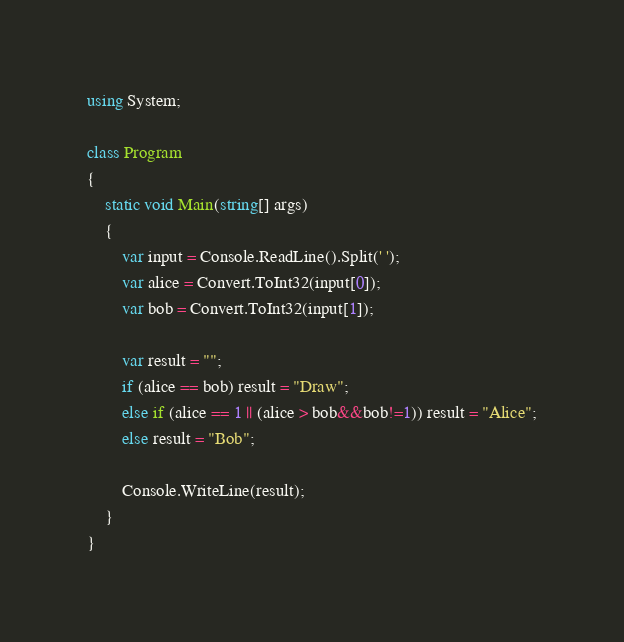<code> <loc_0><loc_0><loc_500><loc_500><_C#_>using System;

class Program
{
    static void Main(string[] args)
    {
        var input = Console.ReadLine().Split(' ');
        var alice = Convert.ToInt32(input[0]);
        var bob = Convert.ToInt32(input[1]);

        var result = "";
        if (alice == bob) result = "Draw";
        else if (alice == 1 || (alice > bob&&bob!=1)) result = "Alice";
        else result = "Bob";

        Console.WriteLine(result);
    }
}</code> 